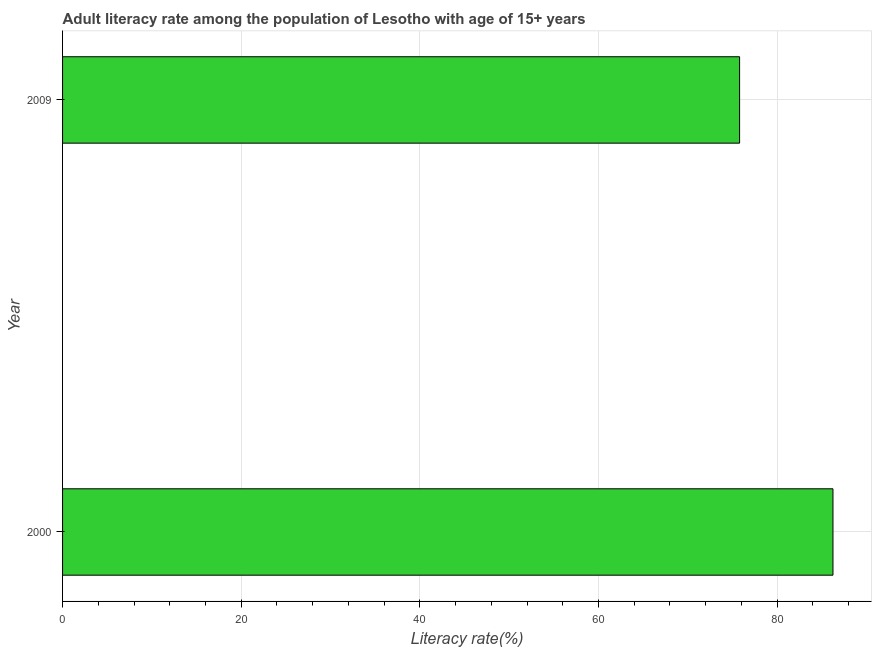Does the graph contain any zero values?
Give a very brief answer. No. Does the graph contain grids?
Ensure brevity in your answer.  Yes. What is the title of the graph?
Your response must be concise. Adult literacy rate among the population of Lesotho with age of 15+ years. What is the label or title of the X-axis?
Make the answer very short. Literacy rate(%). What is the adult literacy rate in 2009?
Give a very brief answer. 75.8. Across all years, what is the maximum adult literacy rate?
Ensure brevity in your answer.  86.25. Across all years, what is the minimum adult literacy rate?
Make the answer very short. 75.8. In which year was the adult literacy rate maximum?
Keep it short and to the point. 2000. In which year was the adult literacy rate minimum?
Your response must be concise. 2009. What is the sum of the adult literacy rate?
Provide a short and direct response. 162.05. What is the difference between the adult literacy rate in 2000 and 2009?
Give a very brief answer. 10.45. What is the average adult literacy rate per year?
Provide a succinct answer. 81.03. What is the median adult literacy rate?
Your response must be concise. 81.03. Do a majority of the years between 2000 and 2009 (inclusive) have adult literacy rate greater than 84 %?
Your answer should be very brief. No. What is the ratio of the adult literacy rate in 2000 to that in 2009?
Your answer should be compact. 1.14. Is the adult literacy rate in 2000 less than that in 2009?
Give a very brief answer. No. How many years are there in the graph?
Your answer should be very brief. 2. What is the Literacy rate(%) of 2000?
Provide a succinct answer. 86.25. What is the Literacy rate(%) in 2009?
Give a very brief answer. 75.8. What is the difference between the Literacy rate(%) in 2000 and 2009?
Ensure brevity in your answer.  10.45. What is the ratio of the Literacy rate(%) in 2000 to that in 2009?
Your answer should be compact. 1.14. 